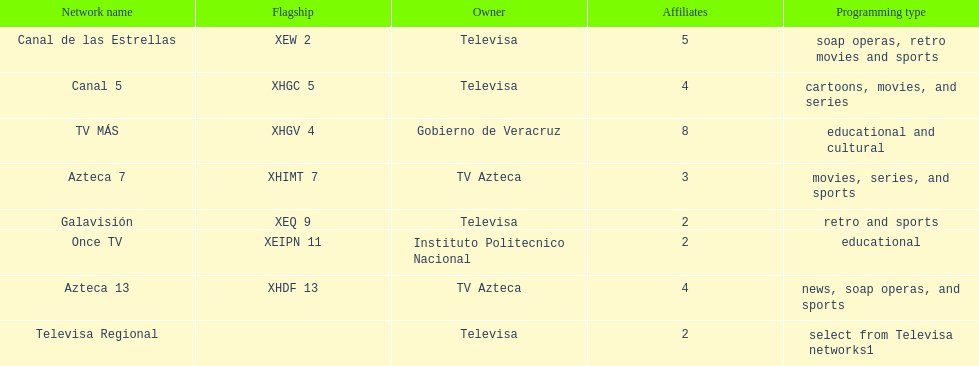Name each of tv azteca's network names. Azteca 7, Azteca 13. 